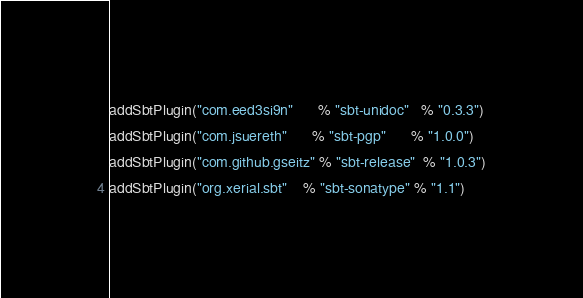<code> <loc_0><loc_0><loc_500><loc_500><_Scala_>addSbtPlugin("com.eed3si9n"      % "sbt-unidoc"   % "0.3.3")
addSbtPlugin("com.jsuereth"      % "sbt-pgp"      % "1.0.0")
addSbtPlugin("com.github.gseitz" % "sbt-release"  % "1.0.3")
addSbtPlugin("org.xerial.sbt"    % "sbt-sonatype" % "1.1")
</code> 